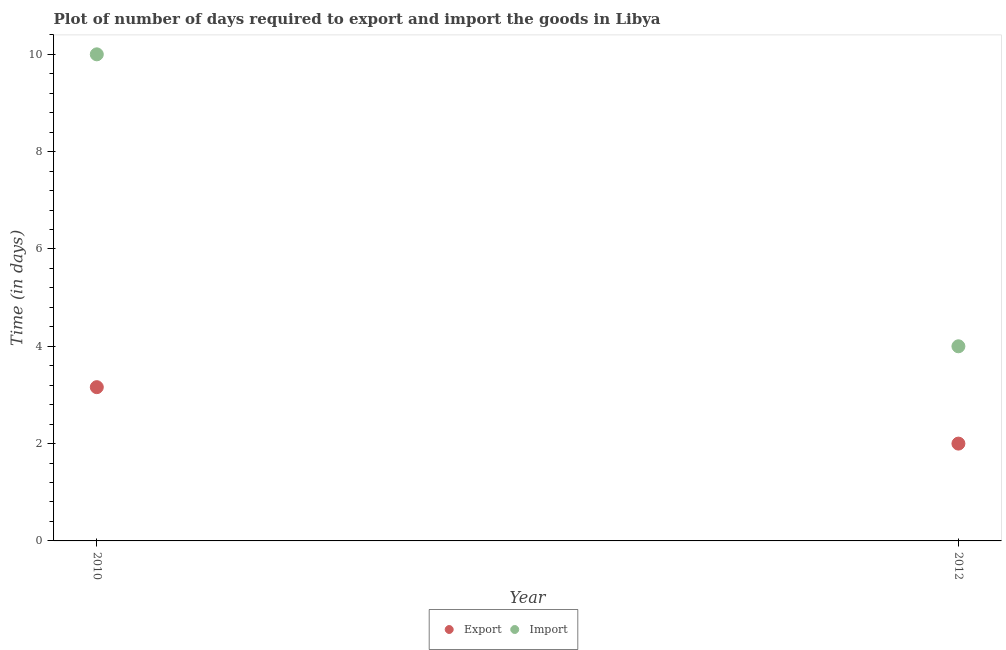What is the time required to export in 2010?
Offer a very short reply. 3.16. Across all years, what is the maximum time required to export?
Ensure brevity in your answer.  3.16. Across all years, what is the minimum time required to export?
Ensure brevity in your answer.  2. In which year was the time required to export maximum?
Ensure brevity in your answer.  2010. In which year was the time required to import minimum?
Offer a terse response. 2012. What is the total time required to import in the graph?
Your answer should be compact. 14. What is the difference between the time required to export in 2010 and that in 2012?
Your answer should be compact. 1.16. What is the difference between the time required to import in 2010 and the time required to export in 2012?
Keep it short and to the point. 8. What is the average time required to export per year?
Your response must be concise. 2.58. In the year 2010, what is the difference between the time required to export and time required to import?
Offer a very short reply. -6.84. Does the time required to export monotonically increase over the years?
Provide a short and direct response. No. Is the time required to import strictly greater than the time required to export over the years?
Your answer should be compact. Yes. How many dotlines are there?
Keep it short and to the point. 2. Does the graph contain any zero values?
Offer a very short reply. No. Does the graph contain grids?
Offer a terse response. No. Where does the legend appear in the graph?
Give a very brief answer. Bottom center. How many legend labels are there?
Offer a very short reply. 2. What is the title of the graph?
Ensure brevity in your answer.  Plot of number of days required to export and import the goods in Libya. What is the label or title of the Y-axis?
Provide a succinct answer. Time (in days). What is the Time (in days) in Export in 2010?
Your answer should be compact. 3.16. What is the Time (in days) of Export in 2012?
Give a very brief answer. 2. Across all years, what is the maximum Time (in days) in Export?
Ensure brevity in your answer.  3.16. Across all years, what is the maximum Time (in days) of Import?
Offer a terse response. 10. Across all years, what is the minimum Time (in days) in Import?
Provide a short and direct response. 4. What is the total Time (in days) of Export in the graph?
Offer a terse response. 5.16. What is the difference between the Time (in days) of Export in 2010 and that in 2012?
Give a very brief answer. 1.16. What is the difference between the Time (in days) in Export in 2010 and the Time (in days) in Import in 2012?
Your answer should be compact. -0.84. What is the average Time (in days) of Export per year?
Provide a succinct answer. 2.58. What is the average Time (in days) of Import per year?
Give a very brief answer. 7. In the year 2010, what is the difference between the Time (in days) of Export and Time (in days) of Import?
Your answer should be very brief. -6.84. What is the ratio of the Time (in days) in Export in 2010 to that in 2012?
Give a very brief answer. 1.58. What is the ratio of the Time (in days) of Import in 2010 to that in 2012?
Offer a very short reply. 2.5. What is the difference between the highest and the second highest Time (in days) of Export?
Offer a very short reply. 1.16. What is the difference between the highest and the lowest Time (in days) of Export?
Your answer should be compact. 1.16. What is the difference between the highest and the lowest Time (in days) of Import?
Offer a very short reply. 6. 